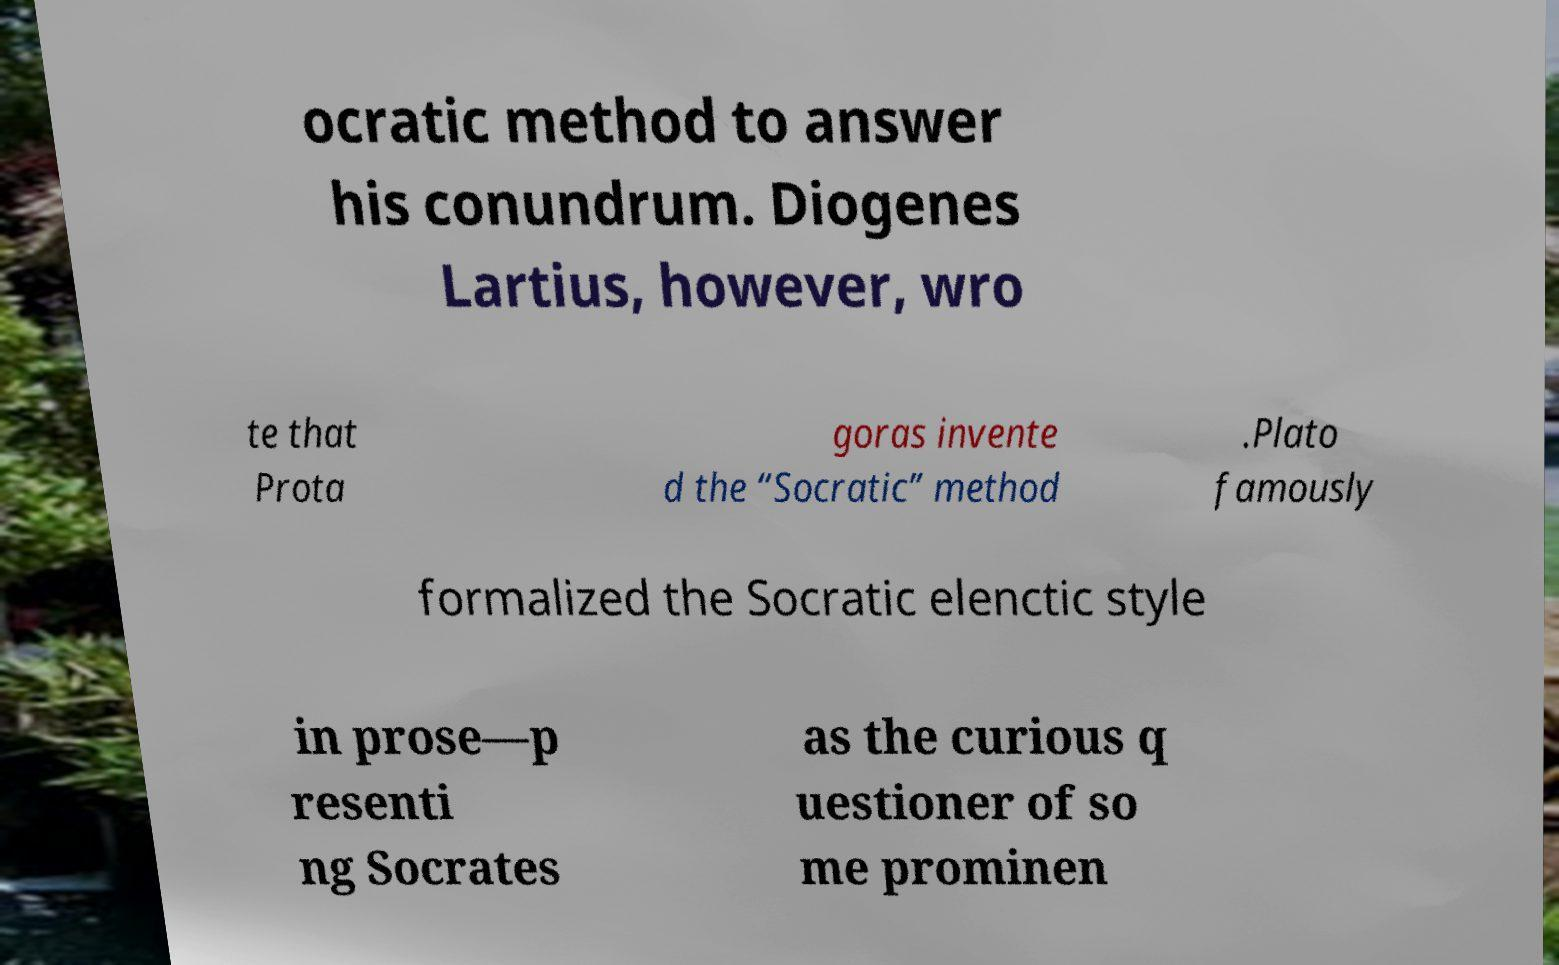There's text embedded in this image that I need extracted. Can you transcribe it verbatim? ocratic method to answer his conundrum. Diogenes Lartius, however, wro te that Prota goras invente d the “Socratic” method .Plato famously formalized the Socratic elenctic style in prose—p resenti ng Socrates as the curious q uestioner of so me prominen 